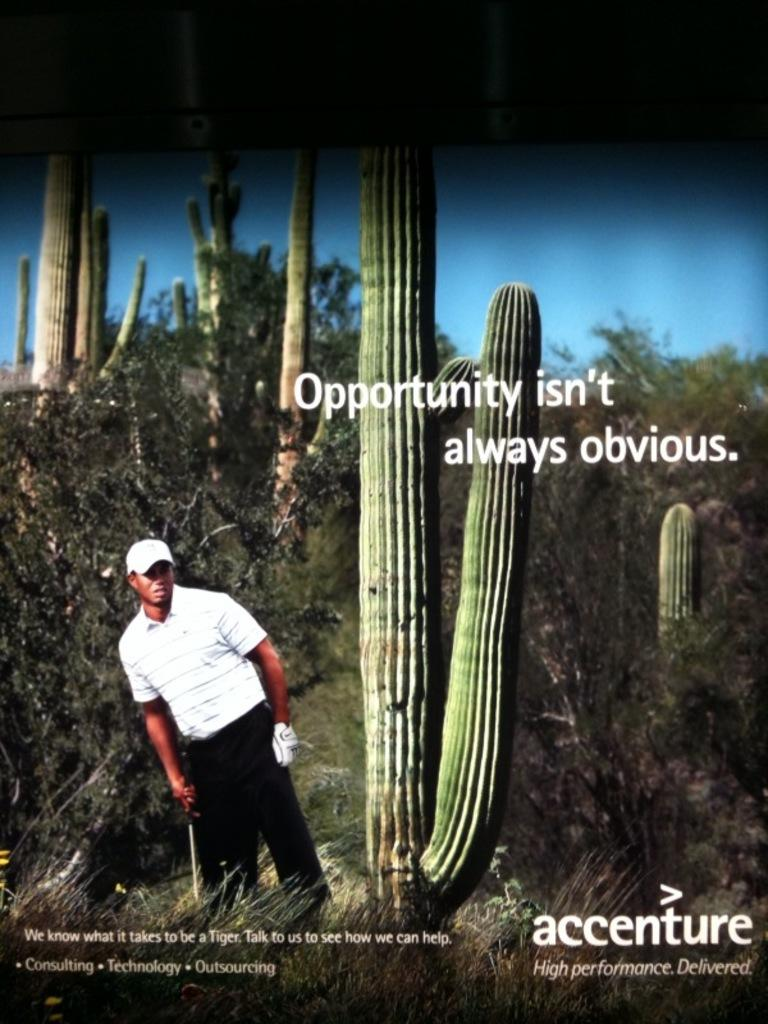What type of vegetation can be seen in the image? There are plants and a cactus in the image. What color is the sky in the image? The sky is blue in the image. What type of ground cover is visible in the image? There is grass visible in the image. Is there a person present in the image? Yes, there is a person in the image. What additional feature can be found in the image? There is text written on the image. What type of operation is being performed on the cactus in the image? There is no operation being performed on the cactus in the image; it is simply a stationary plant. What symbol of peace can be seen in the image? There is no specific symbol of peace present in the image. 